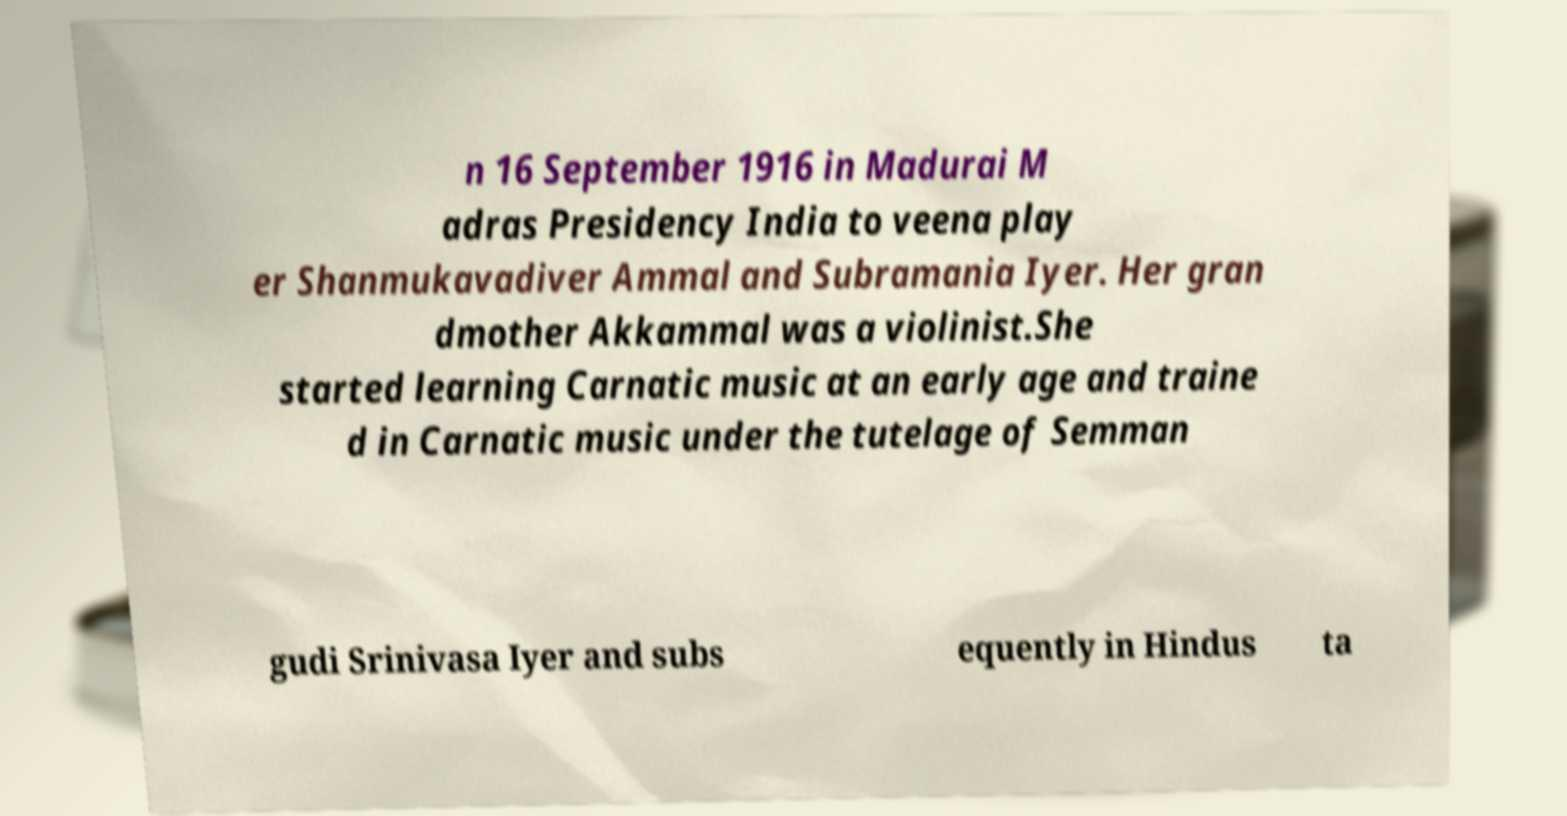Please identify and transcribe the text found in this image. n 16 September 1916 in Madurai M adras Presidency India to veena play er Shanmukavadiver Ammal and Subramania Iyer. Her gran dmother Akkammal was a violinist.She started learning Carnatic music at an early age and traine d in Carnatic music under the tutelage of Semman gudi Srinivasa Iyer and subs equently in Hindus ta 